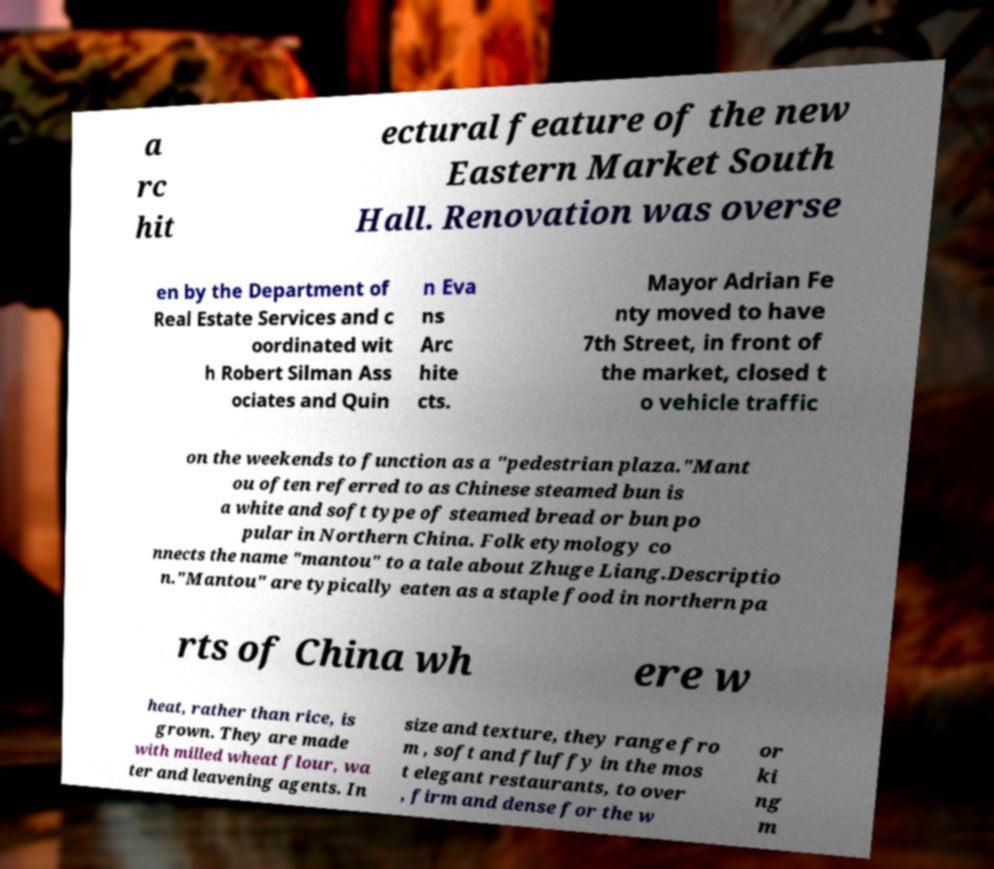For documentation purposes, I need the text within this image transcribed. Could you provide that? a rc hit ectural feature of the new Eastern Market South Hall. Renovation was overse en by the Department of Real Estate Services and c oordinated wit h Robert Silman Ass ociates and Quin n Eva ns Arc hite cts. Mayor Adrian Fe nty moved to have 7th Street, in front of the market, closed t o vehicle traffic on the weekends to function as a "pedestrian plaza."Mant ou often referred to as Chinese steamed bun is a white and soft type of steamed bread or bun po pular in Northern China. Folk etymology co nnects the name "mantou" to a tale about Zhuge Liang.Descriptio n."Mantou" are typically eaten as a staple food in northern pa rts of China wh ere w heat, rather than rice, is grown. They are made with milled wheat flour, wa ter and leavening agents. In size and texture, they range fro m , soft and fluffy in the mos t elegant restaurants, to over , firm and dense for the w or ki ng m 